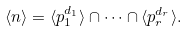<formula> <loc_0><loc_0><loc_500><loc_500>\langle n \rangle = \langle p _ { 1 } ^ { d _ { 1 } } \rangle \cap \cdots \cap \langle p _ { r } ^ { d _ { r } } \rangle .</formula> 